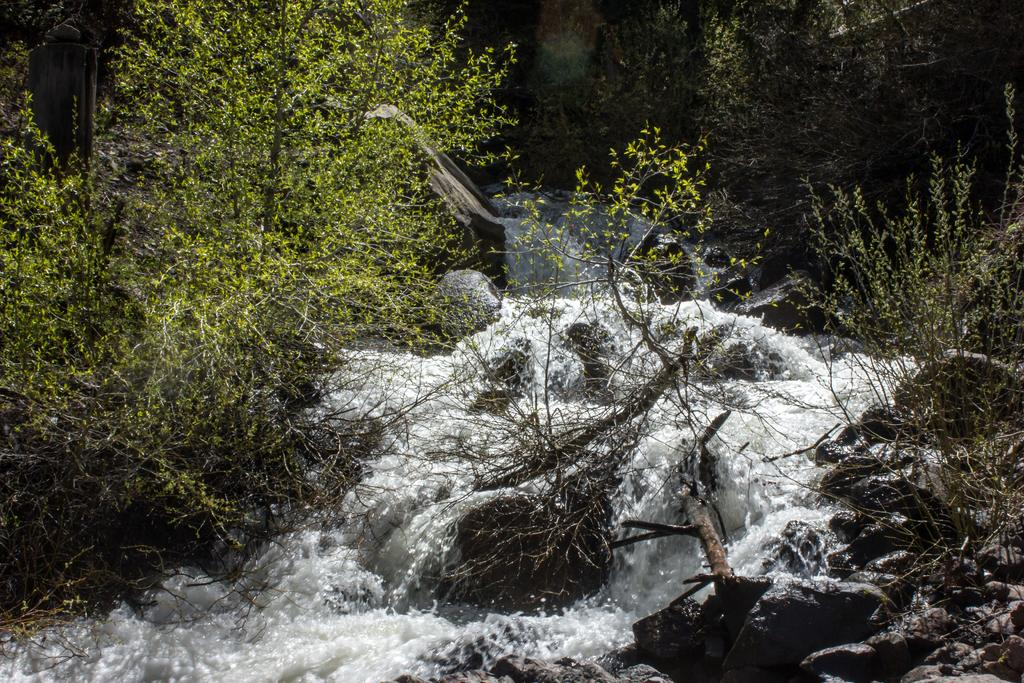What is the main feature in the middle of the image? There is a water flow in the middle of the image. What can be seen on either side of the water flow? There are trees on either side of the water flow. What is present at the bottom of the image? There are stones at the bottom of the image. How many birds are perched on the stones in the image? There are no birds present in the image; it only features a water flow, trees, and stones. 